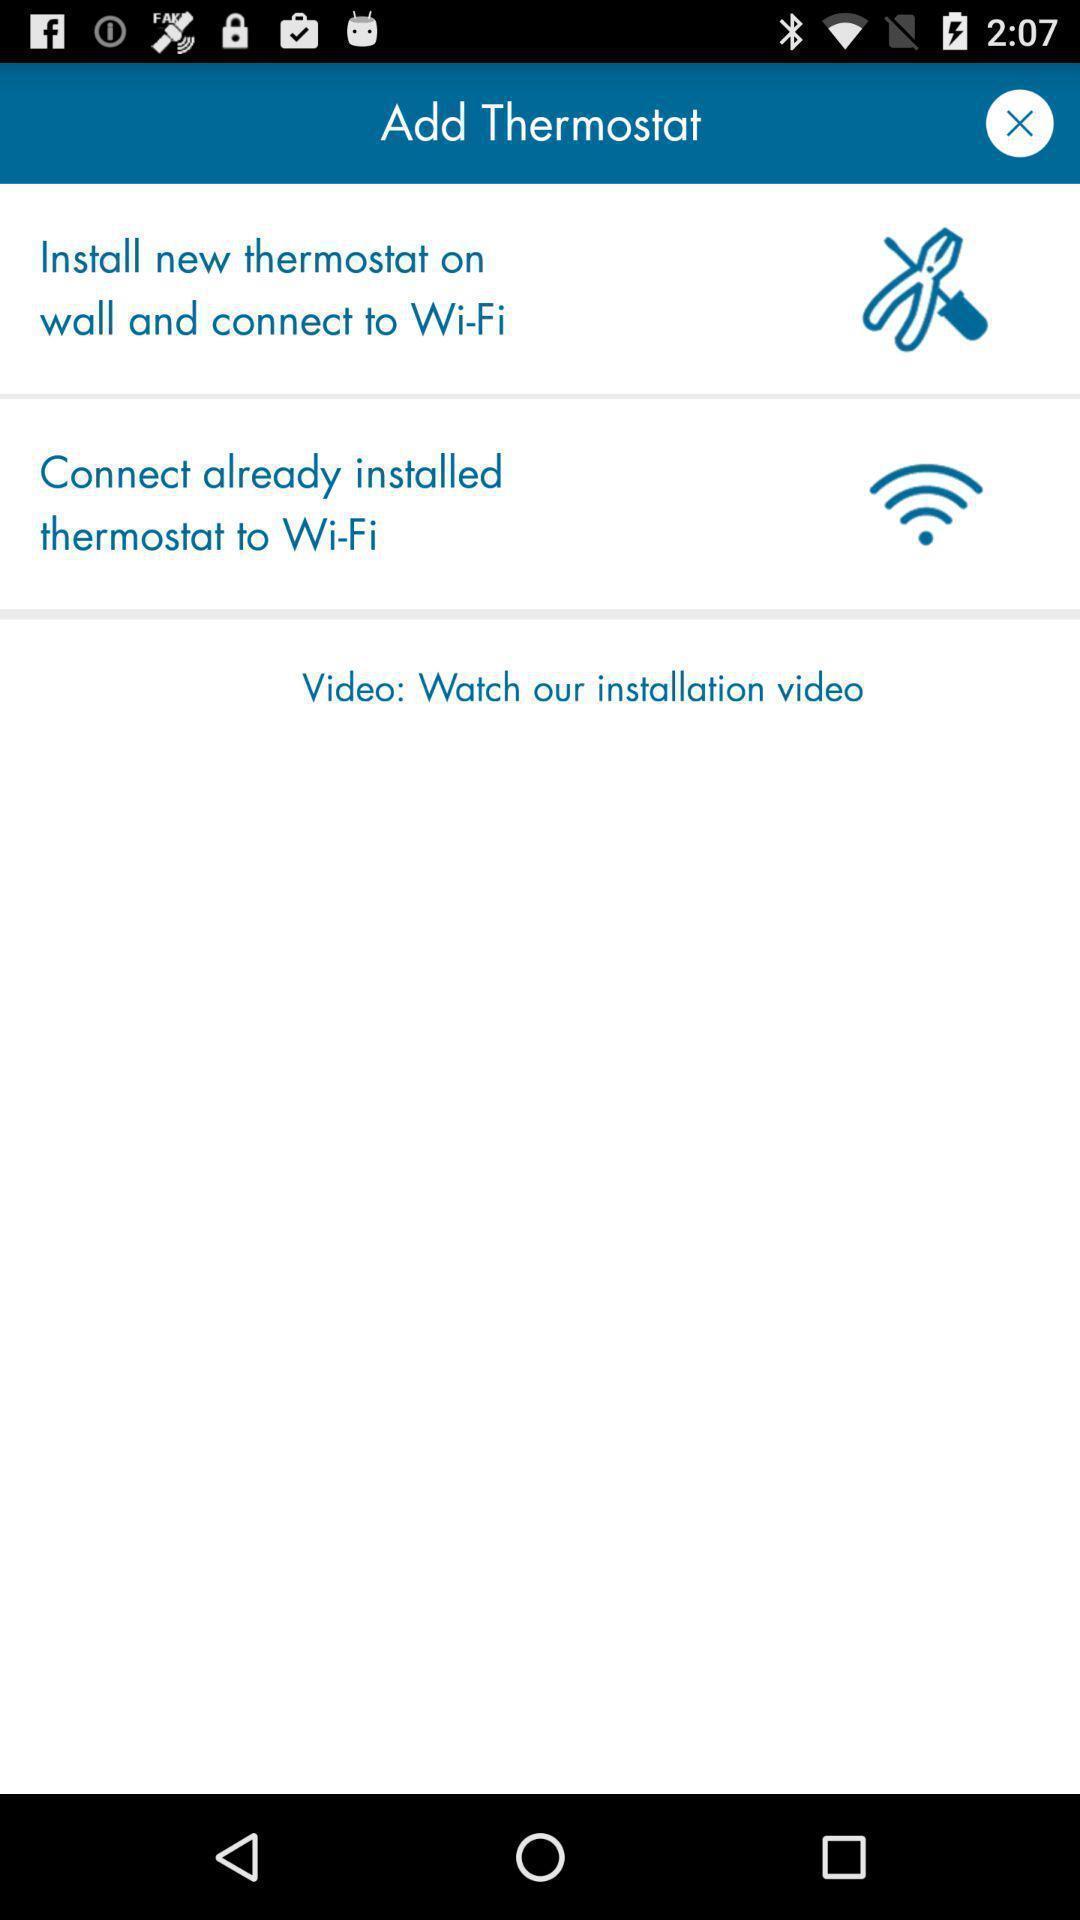Give me a summary of this screen capture. Page showing few options in service app. 